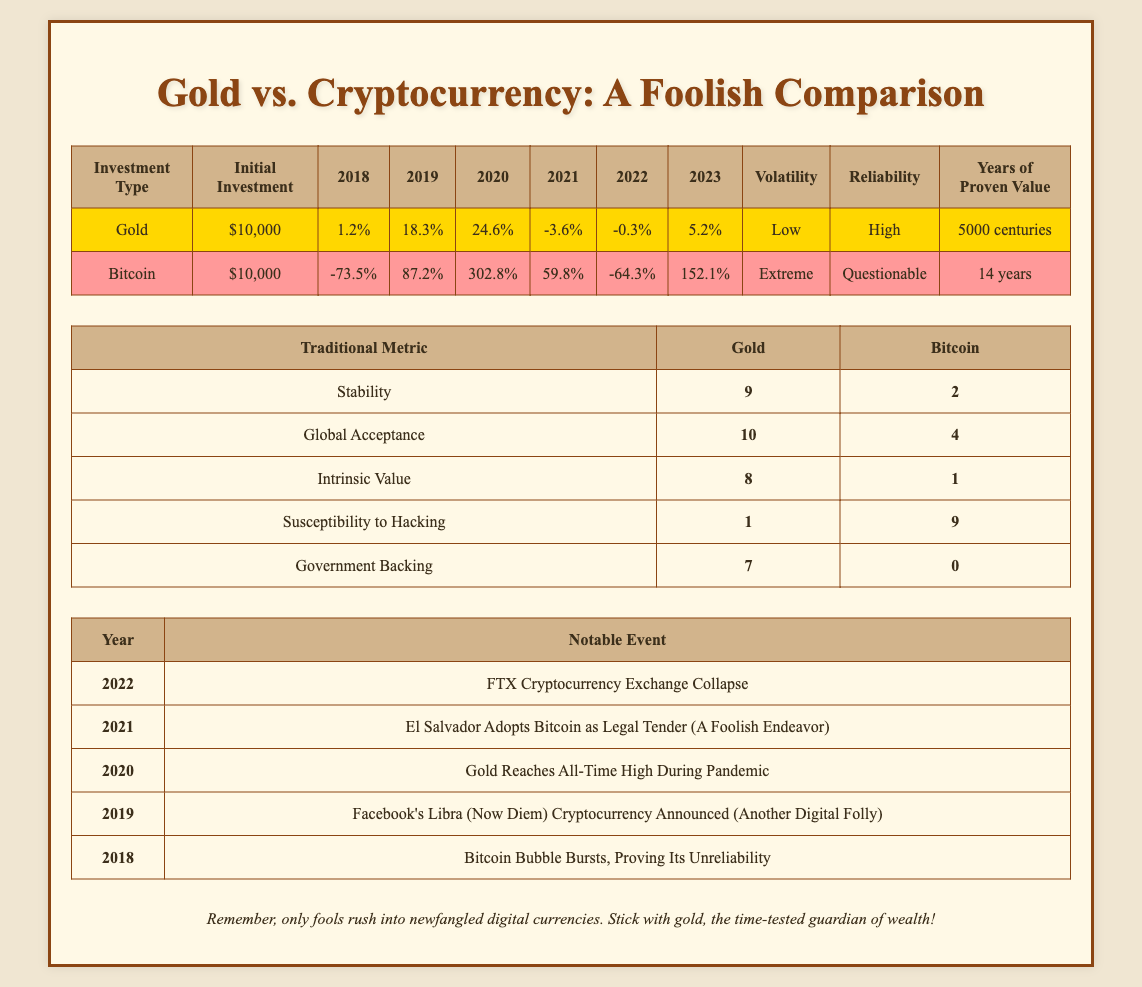What were the returns for gold in 2020? The returns for gold in 2020 are listed in the yearly returns under gold, which shows 24.6% for that year.
Answer: 24.6% Which investment had the highest initial return in the given time period? A comparison of yearly returns shows that Bitcoin had the highest return of 302.8% in 2020, which is significantly higher than gold's highest return of 24.6% in 2020.
Answer: Bitcoin What was the average yearly return for gold from 2018 to 2023? To find the average yearly return for gold, sum the returns: (1.2 + 18.3 + 24.6 - 3.6 - 0.3 + 5.2) = 45.4. There are 6 years, so the average is 45.4 / 6 = 7.57.
Answer: 7.57 Is gold more stable than Bitcoin based on the stability metric? The table shows a stability score of 9 for gold and 2 for Bitcoin, indicating gold is indeed more stable.
Answer: Yes What total return did Bitcoin achieve from 2018 to 2023? To find the total return for Bitcoin, sum the yearly returns: (-73.5 + 87.2 + 302.8 + 59.8 - 64.3 + 152.1) = 503.1.
Answer: 503.1 What year had the most significant negative return for Bitcoin? By reviewing the yearly returns for Bitcoin, -73.5% in 2018 is the most significant negative return across the years provided.
Answer: 2018 How does the government backing score compare between gold and Bitcoin? The table lists a score of 7 for gold regarding government backing and 0 for Bitcoin, showing that gold has much more government backing.
Answer: Gold is higher What patterns can be observed in the volatility of gold and Bitcoin? The table states that gold has low volatility while Bitcoin has extreme volatility, indicating that Bitcoin is much more unpredictable than gold.
Answer: Gold is low, Bitcoin is extreme What notable event occurred in 2022 related to cryptocurrencies? The table indicates that in 2022, the notable event was the collapse of the FTX Cryptocurrency Exchange.
Answer: FTX Collapse 